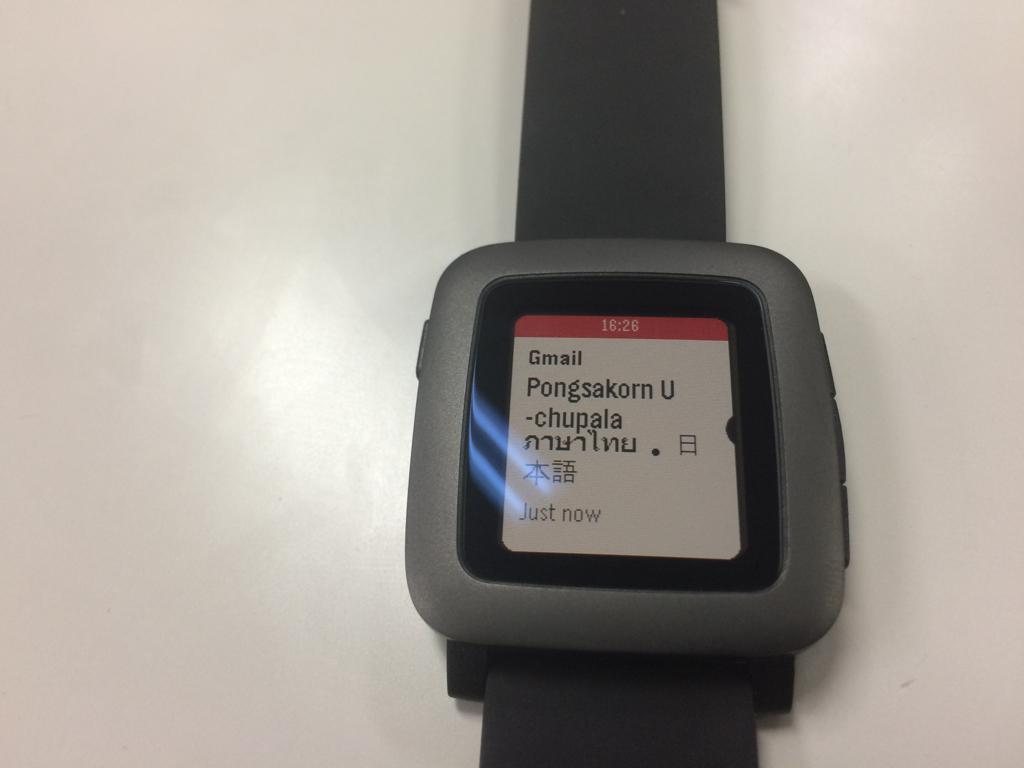<image>
Describe the image concisely. A smart watch at 16:26 showing information from Gmail. 